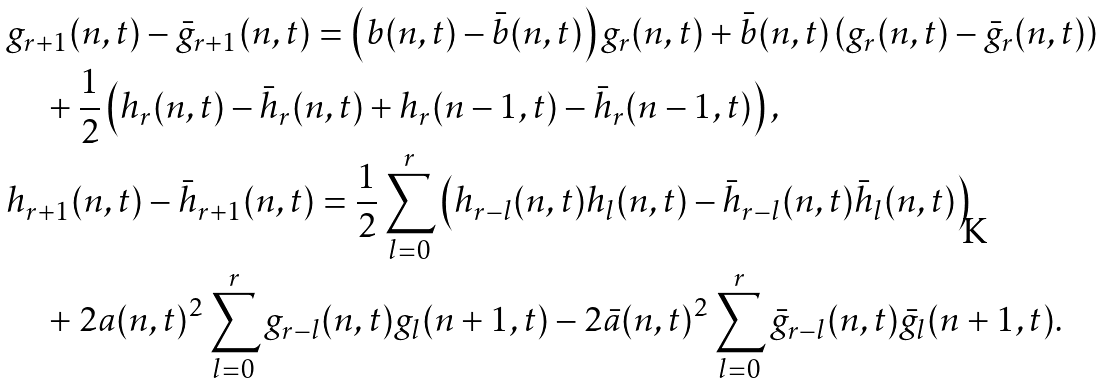Convert formula to latex. <formula><loc_0><loc_0><loc_500><loc_500>& g _ { r + 1 } ( n , t ) - \bar { g } _ { r + 1 } ( n , t ) = \left ( b ( n , t ) - \bar { b } ( n , t ) \right ) g _ { r } ( n , t ) + \bar { b } ( n , t ) \left ( g _ { r } ( n , t ) - \bar { g } _ { r } ( n , t ) \right ) \\ & \quad + \frac { 1 } { 2 } \left ( h _ { r } ( n , t ) - \bar { h } _ { r } ( n , t ) + h _ { r } ( n - 1 , t ) - \bar { h } _ { r } ( n - 1 , t ) \right ) , \\ & h _ { r + 1 } ( n , t ) - \bar { h } _ { r + 1 } ( n , t ) = \frac { 1 } { 2 } \sum _ { l = 0 } ^ { r } \left ( h _ { r - l } ( n , t ) h _ { l } ( n , t ) - \bar { h } _ { r - l } ( n , t ) \bar { h } _ { l } ( n , t ) \right ) \\ & \quad + 2 a ( n , t ) ^ { 2 } \sum _ { l = 0 } ^ { r } g _ { r - l } ( n , t ) g _ { l } ( n + 1 , t ) - 2 \bar { a } ( n , t ) ^ { 2 } \sum _ { l = 0 } ^ { r } \bar { g } _ { r - l } ( n , t ) \bar { g } _ { l } ( n + 1 , t ) .</formula> 